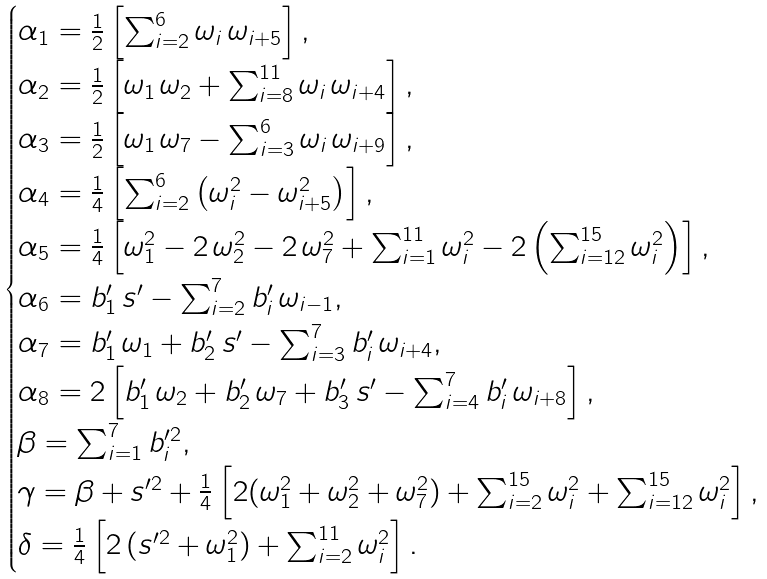<formula> <loc_0><loc_0><loc_500><loc_500>\begin{cases} \alpha _ { 1 } = \frac { 1 } { 2 } \left [ \sum _ { i = 2 } ^ { 6 } \omega _ { i } \, \omega _ { i + 5 } \right ] , & \\ \alpha _ { 2 } = \frac { 1 } { 2 } \left [ \omega _ { 1 } \, \omega _ { 2 } + \sum _ { i = 8 } ^ { 1 1 } \omega _ { i } \, \omega _ { i + 4 } \right ] , & \\ \alpha _ { 3 } = \frac { 1 } { 2 } \left [ \omega _ { 1 } \, \omega _ { 7 } - \sum _ { i = 3 } ^ { 6 } \omega _ { i } \, \omega _ { i + 9 } \right ] , & \\ \alpha _ { 4 } = \frac { 1 } { 4 } \left [ \sum _ { i = 2 } ^ { 6 } \left ( \omega _ { i } ^ { 2 } - \omega _ { i + 5 } ^ { 2 } \right ) \right ] , & \\ \alpha _ { 5 } = \frac { 1 } { 4 } \left [ \omega _ { 1 } ^ { 2 } - 2 \, \omega _ { 2 } ^ { 2 } - 2 \, \omega _ { 7 } ^ { 2 } + \sum _ { i = 1 } ^ { 1 1 } \omega _ { i } ^ { 2 } - 2 \left ( \sum _ { i = 1 2 } ^ { 1 5 } \omega _ { i } ^ { 2 } \right ) \right ] , & \\ \alpha _ { 6 } = b ^ { \prime } _ { 1 } \, s ^ { \prime } - \sum _ { i = 2 } ^ { 7 } b ^ { \prime } _ { i } \, \omega _ { i - 1 } , & \\ \alpha _ { 7 } = b ^ { \prime } _ { 1 } \, \omega _ { 1 } + b ^ { \prime } _ { 2 } \, s ^ { \prime } - \sum _ { i = 3 } ^ { 7 } b ^ { \prime } _ { i } \, \omega _ { i + 4 } , & \\ \alpha _ { 8 } = 2 \left [ b ^ { \prime } _ { 1 } \, \omega _ { 2 } + b ^ { \prime } _ { 2 } \, \omega _ { 7 } + b ^ { \prime } _ { 3 } \, s ^ { \prime } - \sum _ { i = 4 } ^ { 7 } b ^ { \prime } _ { i } \, \omega _ { i + 8 } \right ] , & \\ \beta = \sum _ { i = 1 } ^ { 7 } b _ { i } ^ { \prime 2 } , & \\ \gamma = \beta + s ^ { \prime 2 } + \frac { 1 } { 4 } \left [ 2 ( \omega _ { 1 } ^ { 2 } + \omega _ { 2 } ^ { 2 } + \omega _ { 7 } ^ { 2 } ) + \sum _ { i = 2 } ^ { 1 5 } \omega _ { i } ^ { 2 } + \sum _ { i = 1 2 } ^ { 1 5 } \omega _ { i } ^ { 2 } \right ] , & \\ \delta = \frac { 1 } { 4 } \left [ 2 \, ( s ^ { \prime 2 } + \omega _ { 1 } ^ { 2 } ) + \sum _ { i = 2 } ^ { 1 1 } \omega _ { i } ^ { 2 } \right ] . \end{cases}</formula> 